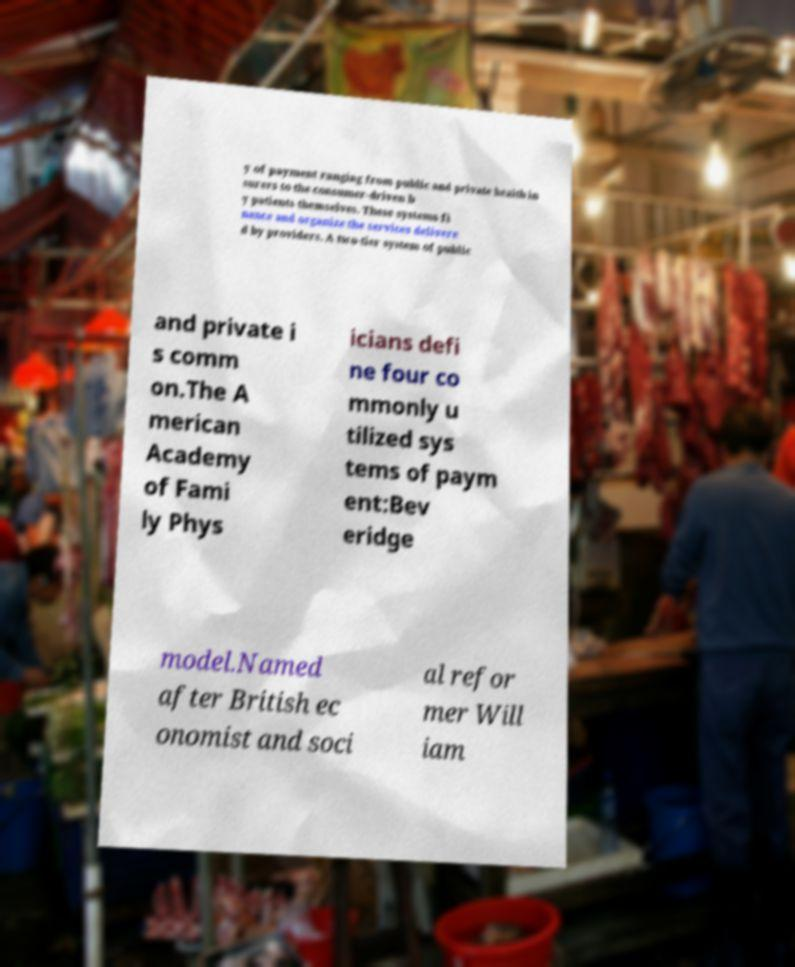There's text embedded in this image that I need extracted. Can you transcribe it verbatim? y of payment ranging from public and private health in surers to the consumer-driven b y patients themselves. These systems fi nance and organize the services delivere d by providers. A two-tier system of public and private i s comm on.The A merican Academy of Fami ly Phys icians defi ne four co mmonly u tilized sys tems of paym ent:Bev eridge model.Named after British ec onomist and soci al refor mer Will iam 